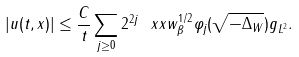<formula> <loc_0><loc_0><loc_500><loc_500>| u ( t , x ) | \leq \frac { C } { t } \sum _ { j \geq 0 } 2 ^ { 2 j } \| \ x x w _ { \beta } ^ { 1 / 2 } \varphi _ { j } ( \sqrt { - \Delta _ { W } } ) g \| _ { L ^ { 2 } } .</formula> 